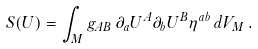Convert formula to latex. <formula><loc_0><loc_0><loc_500><loc_500>S ( U ) = \int _ { M } g _ { A B } \, \partial _ { a } U ^ { A } \partial _ { b } U ^ { B } \eta ^ { a b } \, d V _ { M } \, .</formula> 